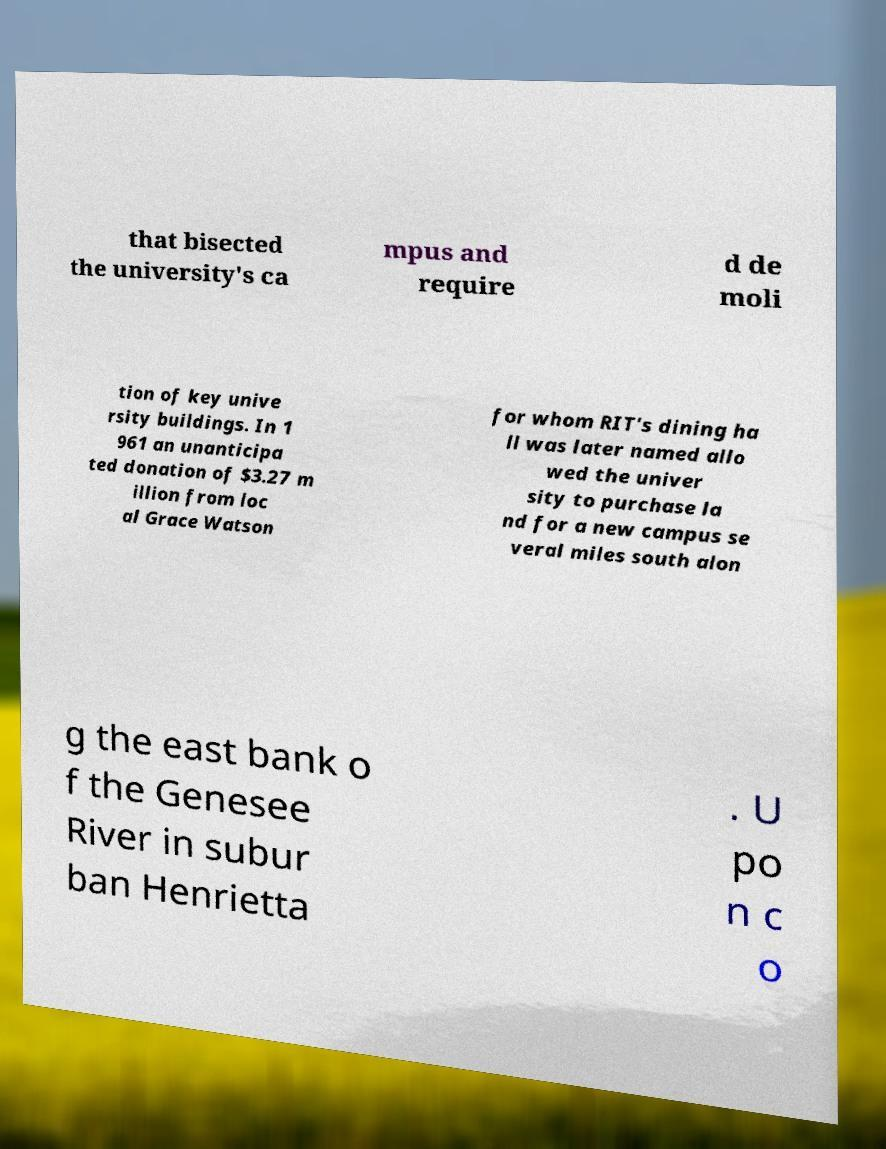Please read and relay the text visible in this image. What does it say? that bisected the university's ca mpus and require d de moli tion of key unive rsity buildings. In 1 961 an unanticipa ted donation of $3.27 m illion from loc al Grace Watson for whom RIT's dining ha ll was later named allo wed the univer sity to purchase la nd for a new campus se veral miles south alon g the east bank o f the Genesee River in subur ban Henrietta . U po n c o 